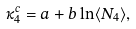<formula> <loc_0><loc_0><loc_500><loc_500>\kappa _ { 4 } ^ { c } = a + b \ln \langle N _ { 4 } \rangle ,</formula> 